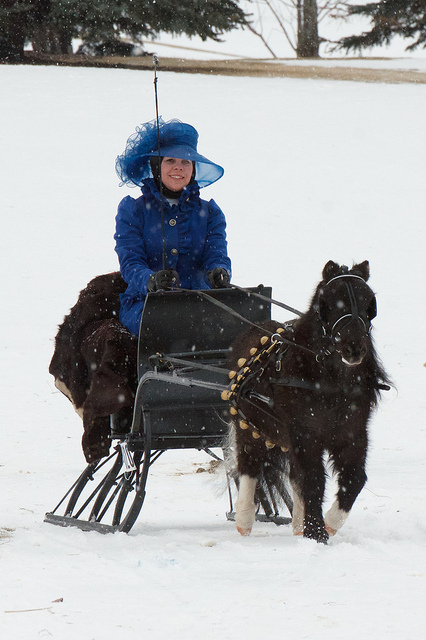How many dogs are playing in the ocean? There are no dogs playing in the ocean in this image. The photo actually shows a person dressed in blue riding a small horse-drawn sled over snow. 